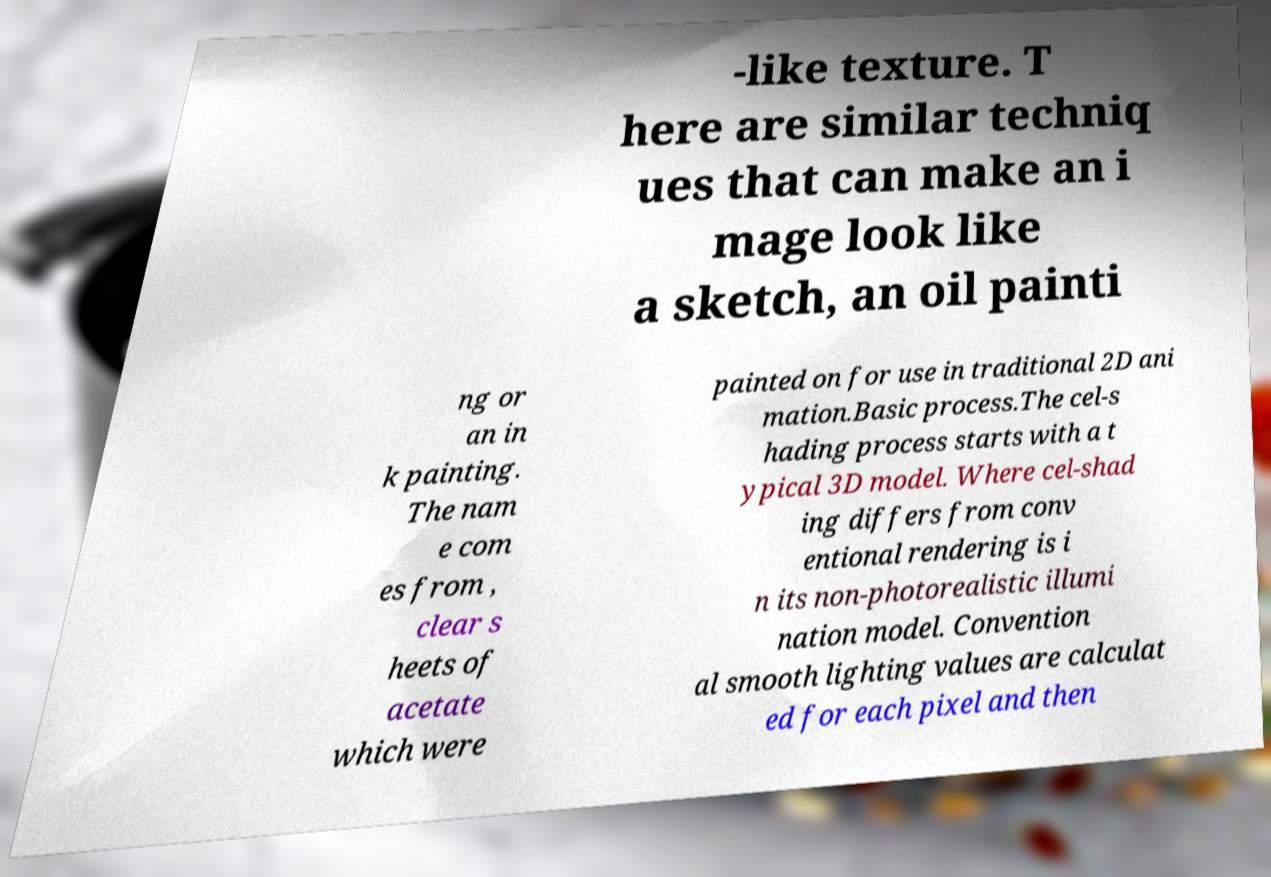Please read and relay the text visible in this image. What does it say? -like texture. T here are similar techniq ues that can make an i mage look like a sketch, an oil painti ng or an in k painting. The nam e com es from , clear s heets of acetate which were painted on for use in traditional 2D ani mation.Basic process.The cel-s hading process starts with a t ypical 3D model. Where cel-shad ing differs from conv entional rendering is i n its non-photorealistic illumi nation model. Convention al smooth lighting values are calculat ed for each pixel and then 